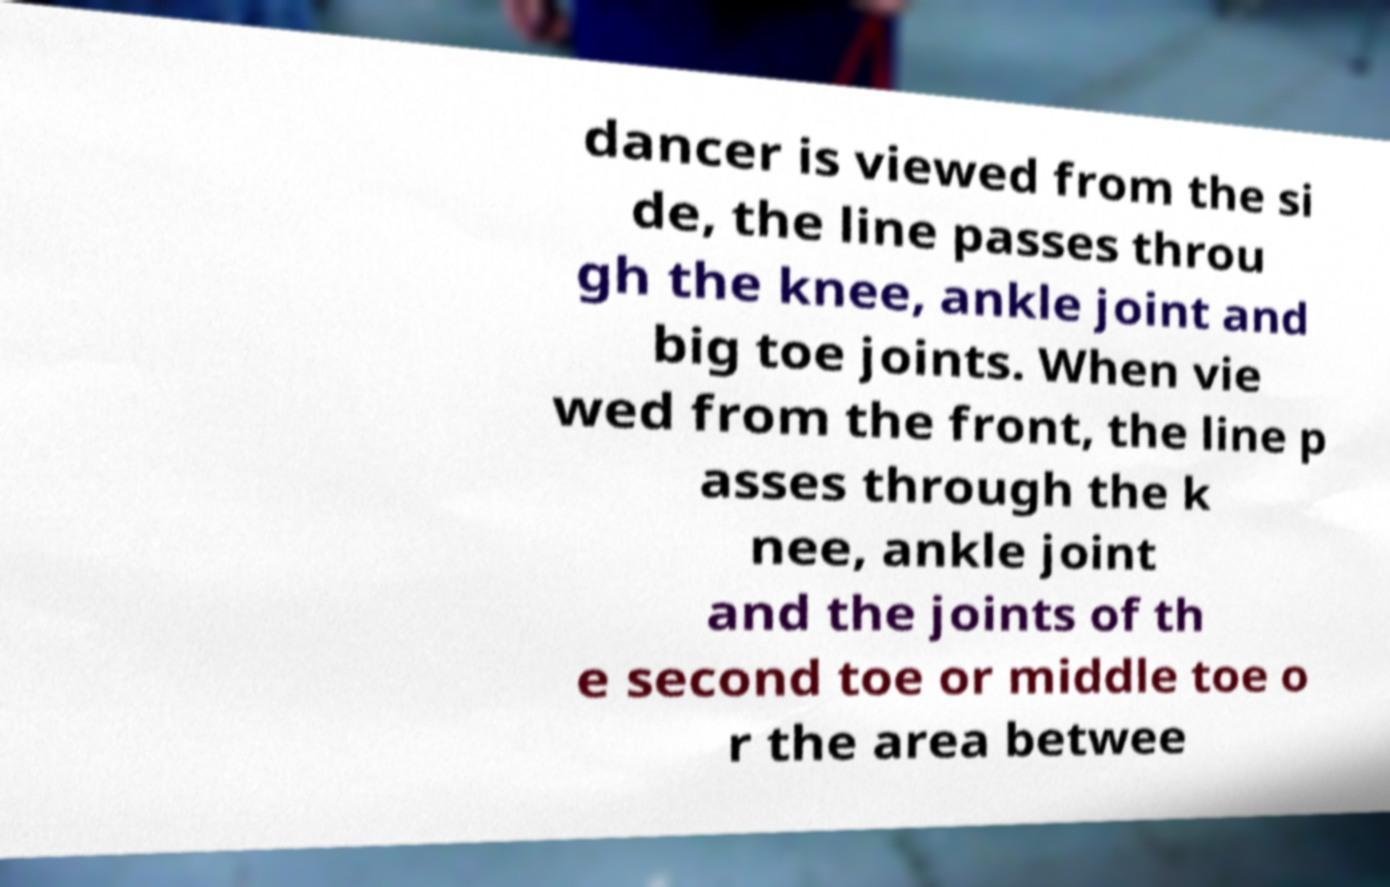Please identify and transcribe the text found in this image. dancer is viewed from the si de, the line passes throu gh the knee, ankle joint and big toe joints. When vie wed from the front, the line p asses through the k nee, ankle joint and the joints of th e second toe or middle toe o r the area betwee 